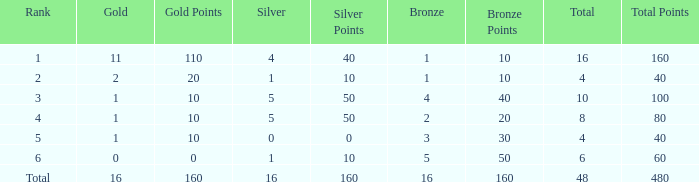How many total gold are less than 4? 0.0. 